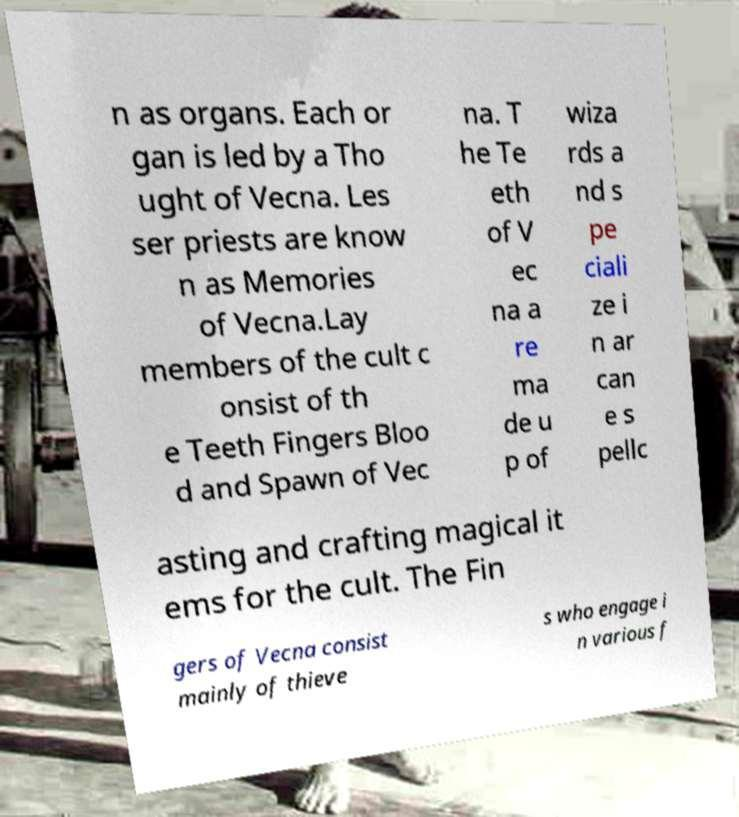Please identify and transcribe the text found in this image. n as organs. Each or gan is led by a Tho ught of Vecna. Les ser priests are know n as Memories of Vecna.Lay members of the cult c onsist of th e Teeth Fingers Bloo d and Spawn of Vec na. T he Te eth of V ec na a re ma de u p of wiza rds a nd s pe ciali ze i n ar can e s pellc asting and crafting magical it ems for the cult. The Fin gers of Vecna consist mainly of thieve s who engage i n various f 